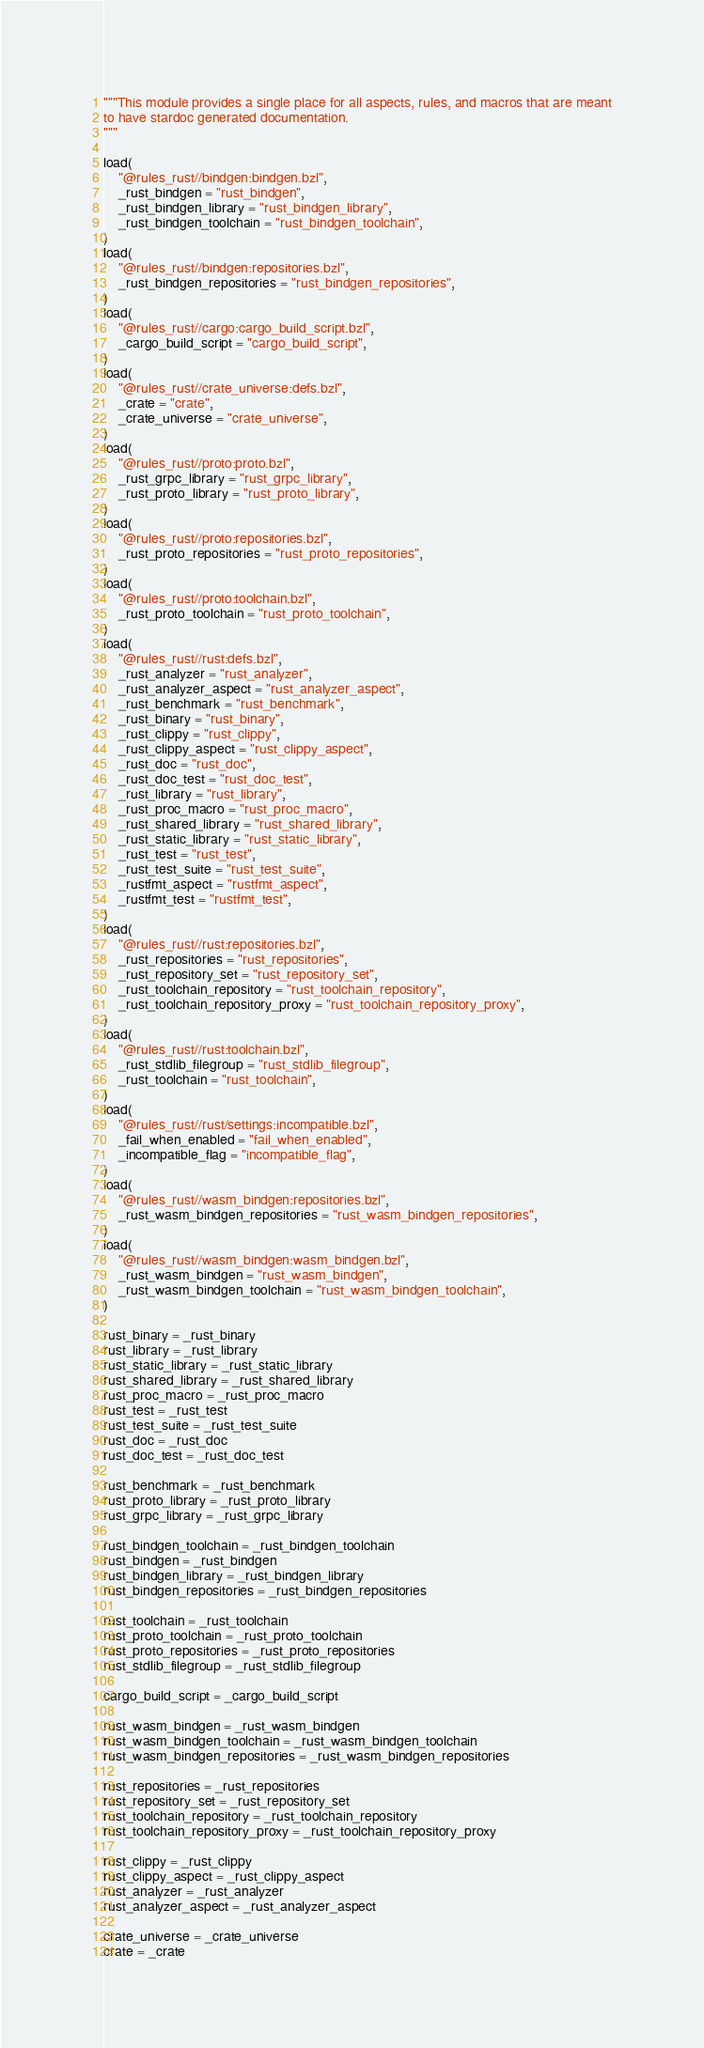Convert code to text. <code><loc_0><loc_0><loc_500><loc_500><_Python_>"""This module provides a single place for all aspects, rules, and macros that are meant
to have stardoc generated documentation.
"""

load(
    "@rules_rust//bindgen:bindgen.bzl",
    _rust_bindgen = "rust_bindgen",
    _rust_bindgen_library = "rust_bindgen_library",
    _rust_bindgen_toolchain = "rust_bindgen_toolchain",
)
load(
    "@rules_rust//bindgen:repositories.bzl",
    _rust_bindgen_repositories = "rust_bindgen_repositories",
)
load(
    "@rules_rust//cargo:cargo_build_script.bzl",
    _cargo_build_script = "cargo_build_script",
)
load(
    "@rules_rust//crate_universe:defs.bzl",
    _crate = "crate",
    _crate_universe = "crate_universe",
)
load(
    "@rules_rust//proto:proto.bzl",
    _rust_grpc_library = "rust_grpc_library",
    _rust_proto_library = "rust_proto_library",
)
load(
    "@rules_rust//proto:repositories.bzl",
    _rust_proto_repositories = "rust_proto_repositories",
)
load(
    "@rules_rust//proto:toolchain.bzl",
    _rust_proto_toolchain = "rust_proto_toolchain",
)
load(
    "@rules_rust//rust:defs.bzl",
    _rust_analyzer = "rust_analyzer",
    _rust_analyzer_aspect = "rust_analyzer_aspect",
    _rust_benchmark = "rust_benchmark",
    _rust_binary = "rust_binary",
    _rust_clippy = "rust_clippy",
    _rust_clippy_aspect = "rust_clippy_aspect",
    _rust_doc = "rust_doc",
    _rust_doc_test = "rust_doc_test",
    _rust_library = "rust_library",
    _rust_proc_macro = "rust_proc_macro",
    _rust_shared_library = "rust_shared_library",
    _rust_static_library = "rust_static_library",
    _rust_test = "rust_test",
    _rust_test_suite = "rust_test_suite",
    _rustfmt_aspect = "rustfmt_aspect",
    _rustfmt_test = "rustfmt_test",
)
load(
    "@rules_rust//rust:repositories.bzl",
    _rust_repositories = "rust_repositories",
    _rust_repository_set = "rust_repository_set",
    _rust_toolchain_repository = "rust_toolchain_repository",
    _rust_toolchain_repository_proxy = "rust_toolchain_repository_proxy",
)
load(
    "@rules_rust//rust:toolchain.bzl",
    _rust_stdlib_filegroup = "rust_stdlib_filegroup",
    _rust_toolchain = "rust_toolchain",
)
load(
    "@rules_rust//rust/settings:incompatible.bzl",
    _fail_when_enabled = "fail_when_enabled",
    _incompatible_flag = "incompatible_flag",
)
load(
    "@rules_rust//wasm_bindgen:repositories.bzl",
    _rust_wasm_bindgen_repositories = "rust_wasm_bindgen_repositories",
)
load(
    "@rules_rust//wasm_bindgen:wasm_bindgen.bzl",
    _rust_wasm_bindgen = "rust_wasm_bindgen",
    _rust_wasm_bindgen_toolchain = "rust_wasm_bindgen_toolchain",
)

rust_binary = _rust_binary
rust_library = _rust_library
rust_static_library = _rust_static_library
rust_shared_library = _rust_shared_library
rust_proc_macro = _rust_proc_macro
rust_test = _rust_test
rust_test_suite = _rust_test_suite
rust_doc = _rust_doc
rust_doc_test = _rust_doc_test

rust_benchmark = _rust_benchmark
rust_proto_library = _rust_proto_library
rust_grpc_library = _rust_grpc_library

rust_bindgen_toolchain = _rust_bindgen_toolchain
rust_bindgen = _rust_bindgen
rust_bindgen_library = _rust_bindgen_library
rust_bindgen_repositories = _rust_bindgen_repositories

rust_toolchain = _rust_toolchain
rust_proto_toolchain = _rust_proto_toolchain
rust_proto_repositories = _rust_proto_repositories
rust_stdlib_filegroup = _rust_stdlib_filegroup

cargo_build_script = _cargo_build_script

rust_wasm_bindgen = _rust_wasm_bindgen
rust_wasm_bindgen_toolchain = _rust_wasm_bindgen_toolchain
rust_wasm_bindgen_repositories = _rust_wasm_bindgen_repositories

rust_repositories = _rust_repositories
rust_repository_set = _rust_repository_set
rust_toolchain_repository = _rust_toolchain_repository
rust_toolchain_repository_proxy = _rust_toolchain_repository_proxy

rust_clippy = _rust_clippy
rust_clippy_aspect = _rust_clippy_aspect
rust_analyzer = _rust_analyzer
rust_analyzer_aspect = _rust_analyzer_aspect

crate_universe = _crate_universe
crate = _crate
</code> 